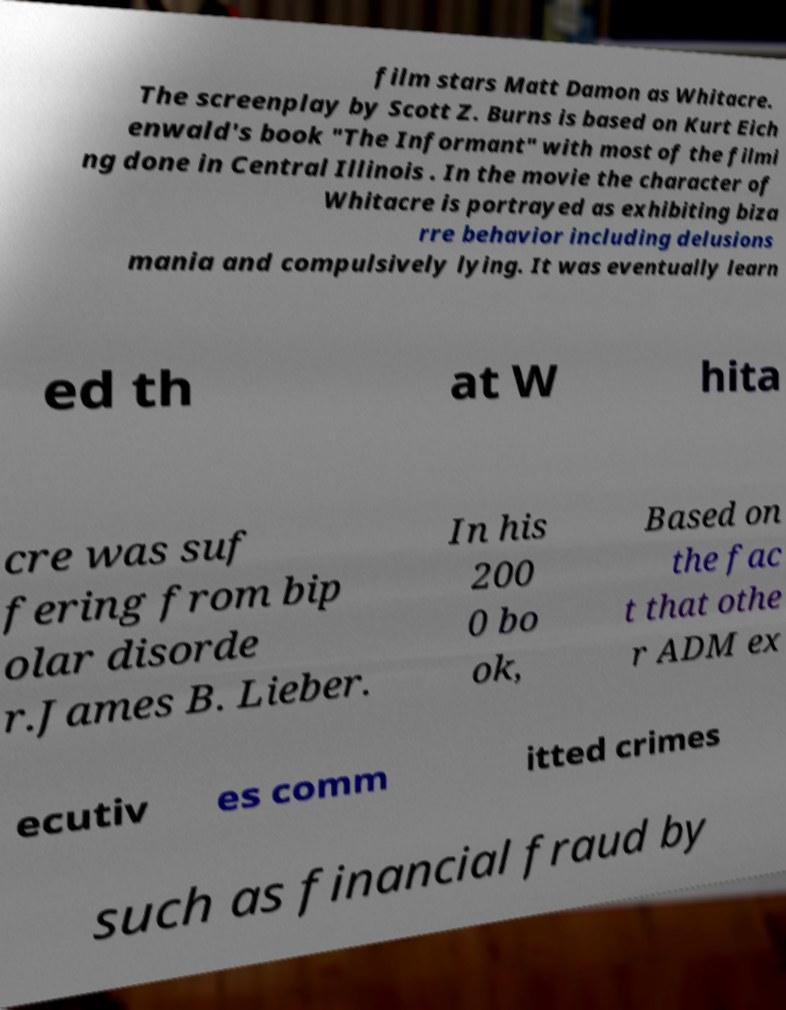Can you read and provide the text displayed in the image?This photo seems to have some interesting text. Can you extract and type it out for me? film stars Matt Damon as Whitacre. The screenplay by Scott Z. Burns is based on Kurt Eich enwald's book "The Informant" with most of the filmi ng done in Central Illinois . In the movie the character of Whitacre is portrayed as exhibiting biza rre behavior including delusions mania and compulsively lying. It was eventually learn ed th at W hita cre was suf fering from bip olar disorde r.James B. Lieber. In his 200 0 bo ok, Based on the fac t that othe r ADM ex ecutiv es comm itted crimes such as financial fraud by 